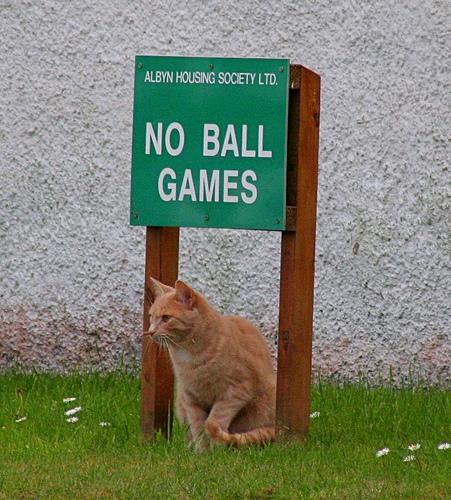Is this a friendly park area?
Give a very brief answer. No. What is not allowed, according to the sign?
Be succinct. Ball games. What color is this cat?
Be succinct. Orange. Who maintains this area?
Concise answer only. Albyn housing society ltd. 